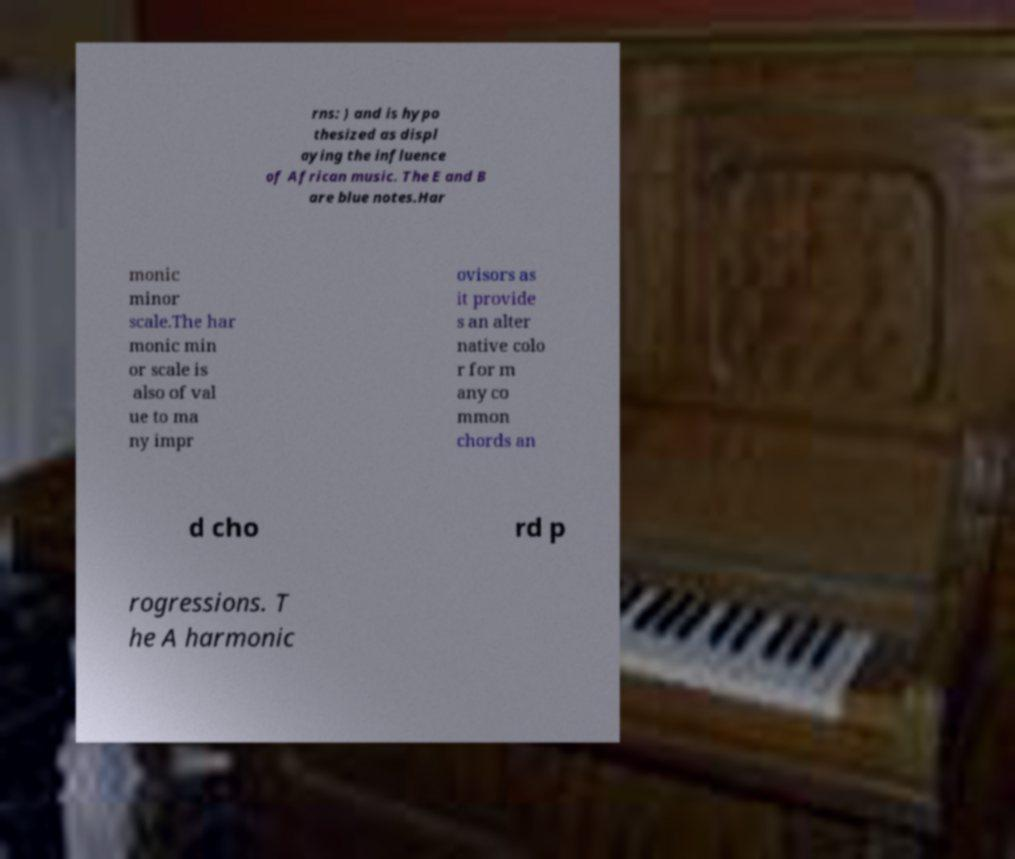Could you extract and type out the text from this image? rns: ) and is hypo thesized as displ aying the influence of African music. The E and B are blue notes.Har monic minor scale.The har monic min or scale is also of val ue to ma ny impr ovisors as it provide s an alter native colo r for m any co mmon chords an d cho rd p rogressions. T he A harmonic 